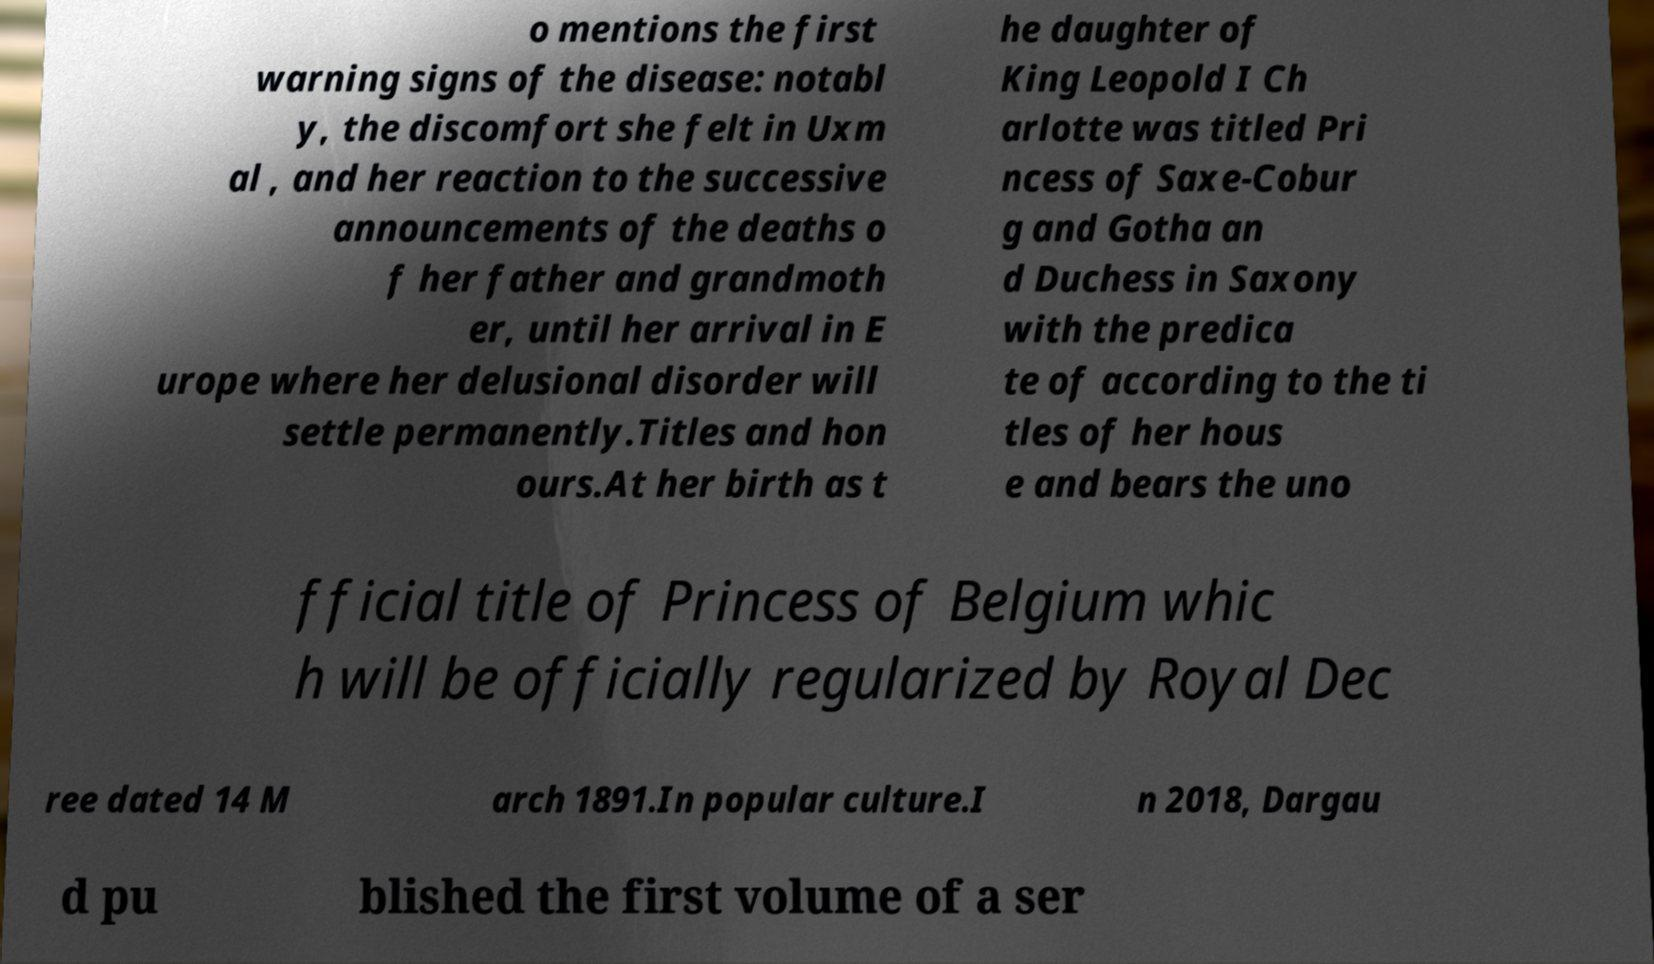I need the written content from this picture converted into text. Can you do that? o mentions the first warning signs of the disease: notabl y, the discomfort she felt in Uxm al , and her reaction to the successive announcements of the deaths o f her father and grandmoth er, until her arrival in E urope where her delusional disorder will settle permanently.Titles and hon ours.At her birth as t he daughter of King Leopold I Ch arlotte was titled Pri ncess of Saxe-Cobur g and Gotha an d Duchess in Saxony with the predica te of according to the ti tles of her hous e and bears the uno fficial title of Princess of Belgium whic h will be officially regularized by Royal Dec ree dated 14 M arch 1891.In popular culture.I n 2018, Dargau d pu blished the first volume of a ser 